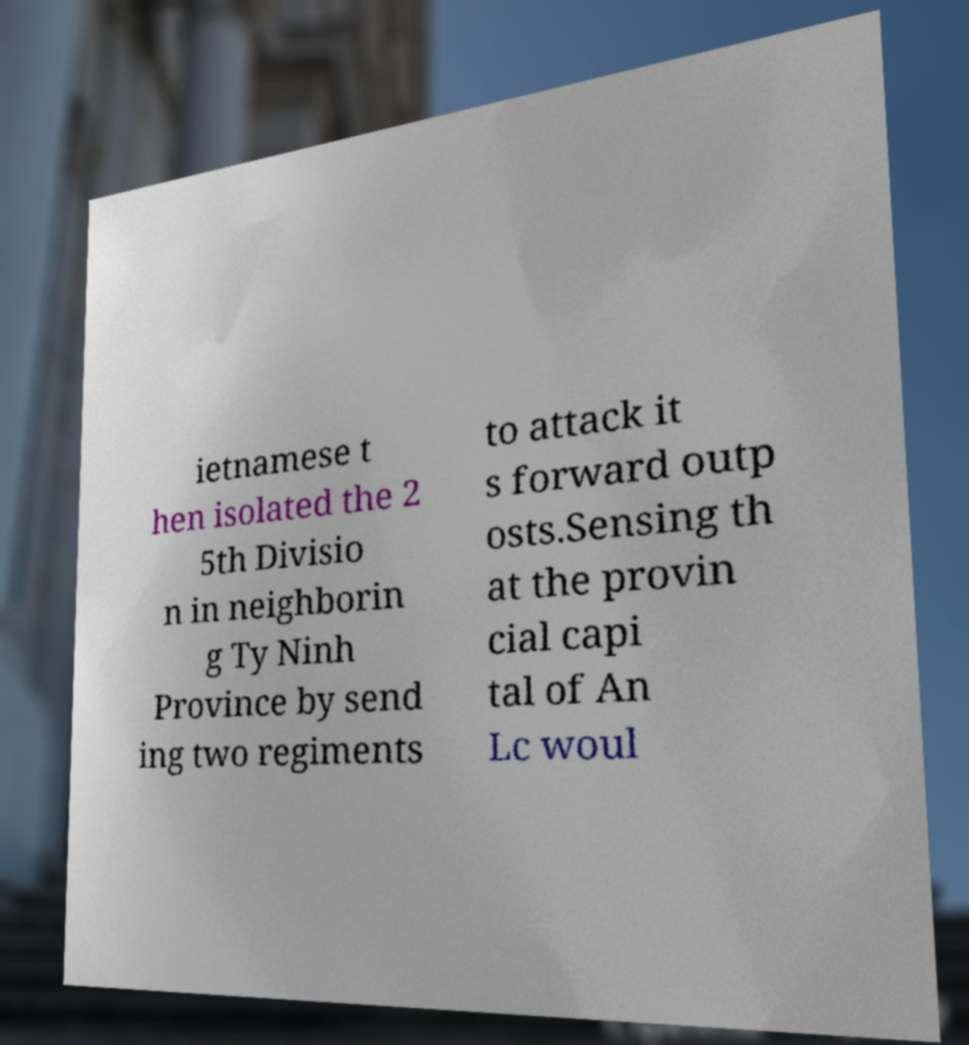Please read and relay the text visible in this image. What does it say? ietnamese t hen isolated the 2 5th Divisio n in neighborin g Ty Ninh Province by send ing two regiments to attack it s forward outp osts.Sensing th at the provin cial capi tal of An Lc woul 